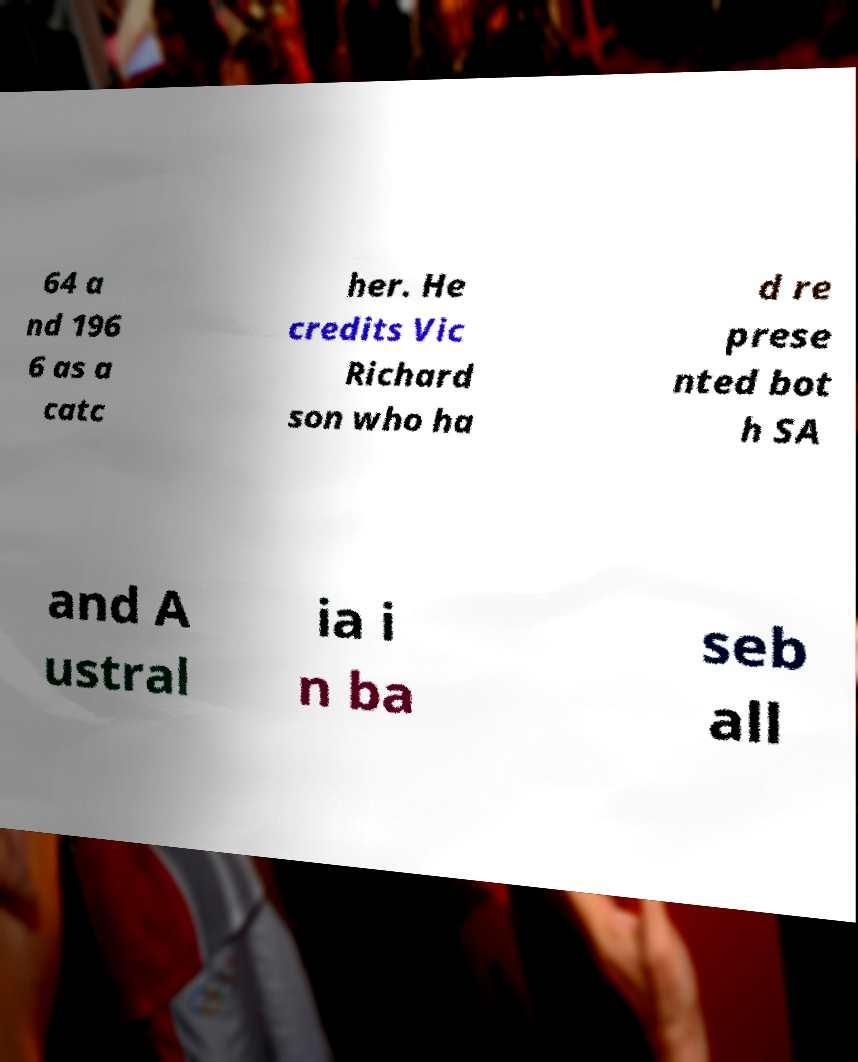There's text embedded in this image that I need extracted. Can you transcribe it verbatim? 64 a nd 196 6 as a catc her. He credits Vic Richard son who ha d re prese nted bot h SA and A ustral ia i n ba seb all 